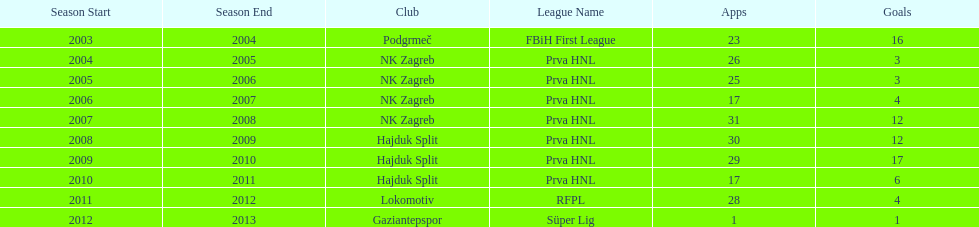The team with the most goals Hajduk Split. 